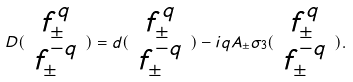Convert formula to latex. <formula><loc_0><loc_0><loc_500><loc_500>D ( \begin{array} { c } f _ { \pm } ^ { q } \\ f _ { \pm } ^ { - q } \end{array} ) = d ( \begin{array} { c } f _ { \pm } ^ { q } \\ f _ { \pm } ^ { - q } \end{array} ) - i q A _ { \pm } \sigma _ { 3 } ( \begin{array} { c } f _ { \pm } ^ { q } \\ f _ { \pm } ^ { - q } \end{array} ) .</formula> 